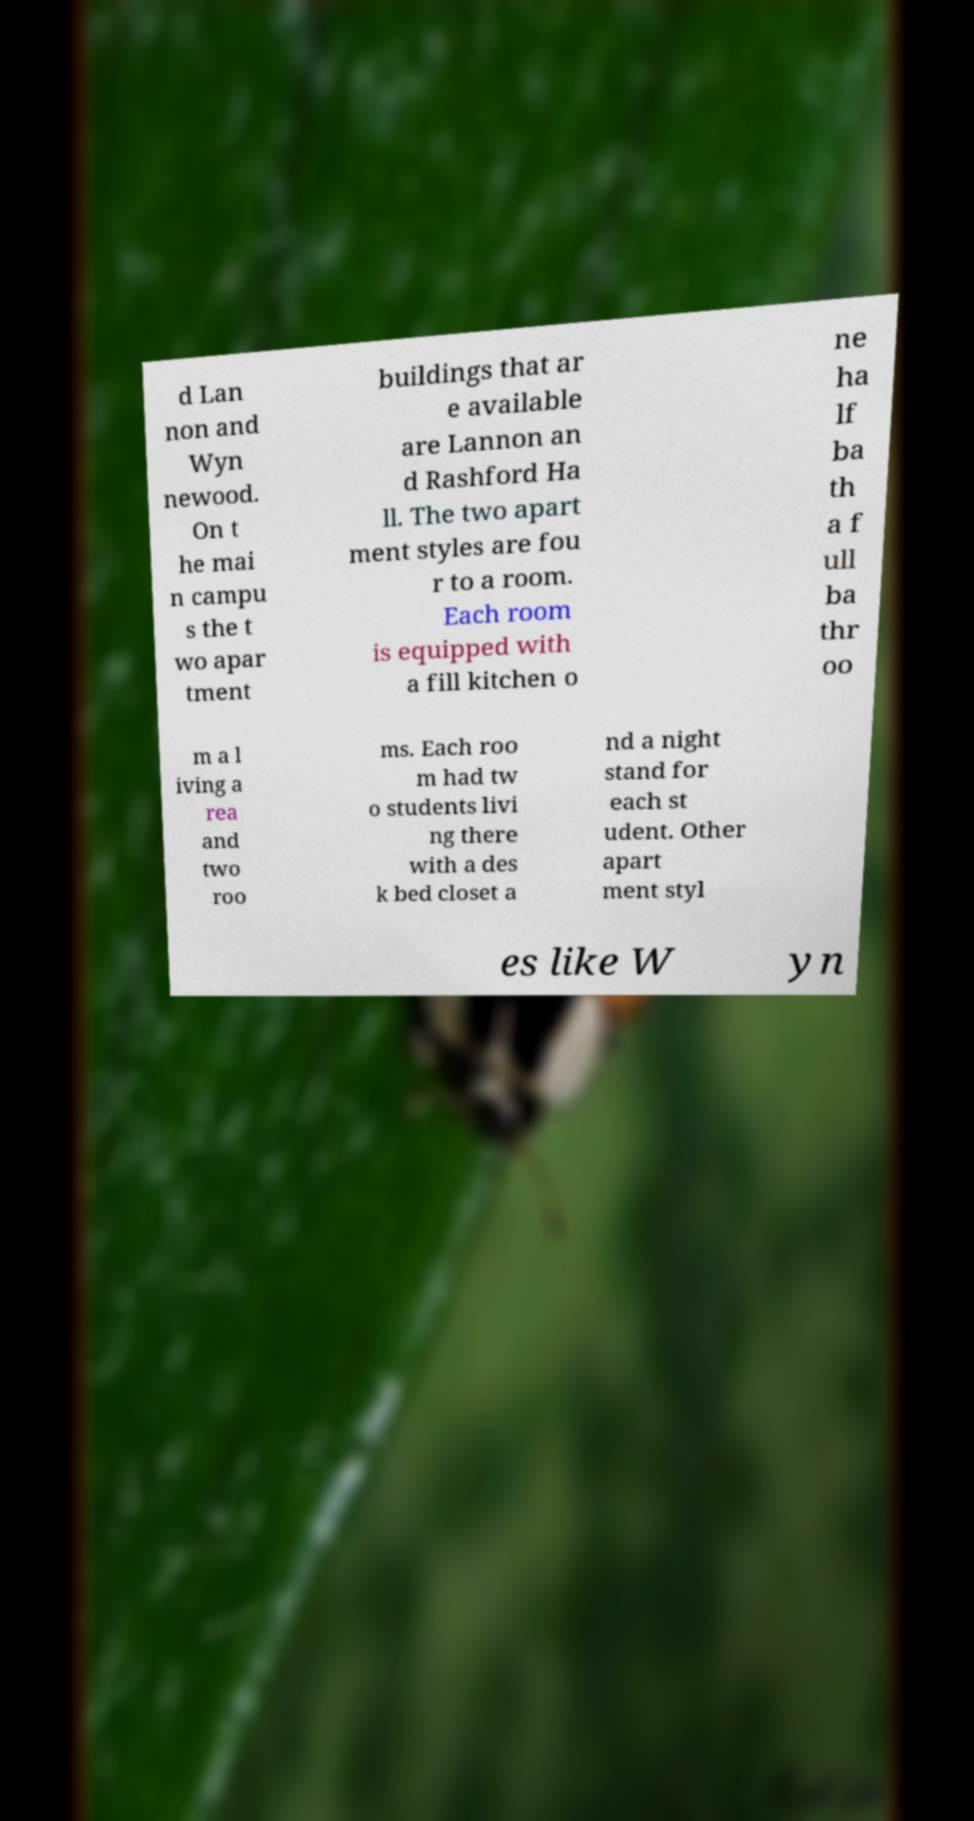Could you extract and type out the text from this image? d Lan non and Wyn newood. On t he mai n campu s the t wo apar tment buildings that ar e available are Lannon an d Rashford Ha ll. The two apart ment styles are fou r to a room. Each room is equipped with a fill kitchen o ne ha lf ba th a f ull ba thr oo m a l iving a rea and two roo ms. Each roo m had tw o students livi ng there with a des k bed closet a nd a night stand for each st udent. Other apart ment styl es like W yn 